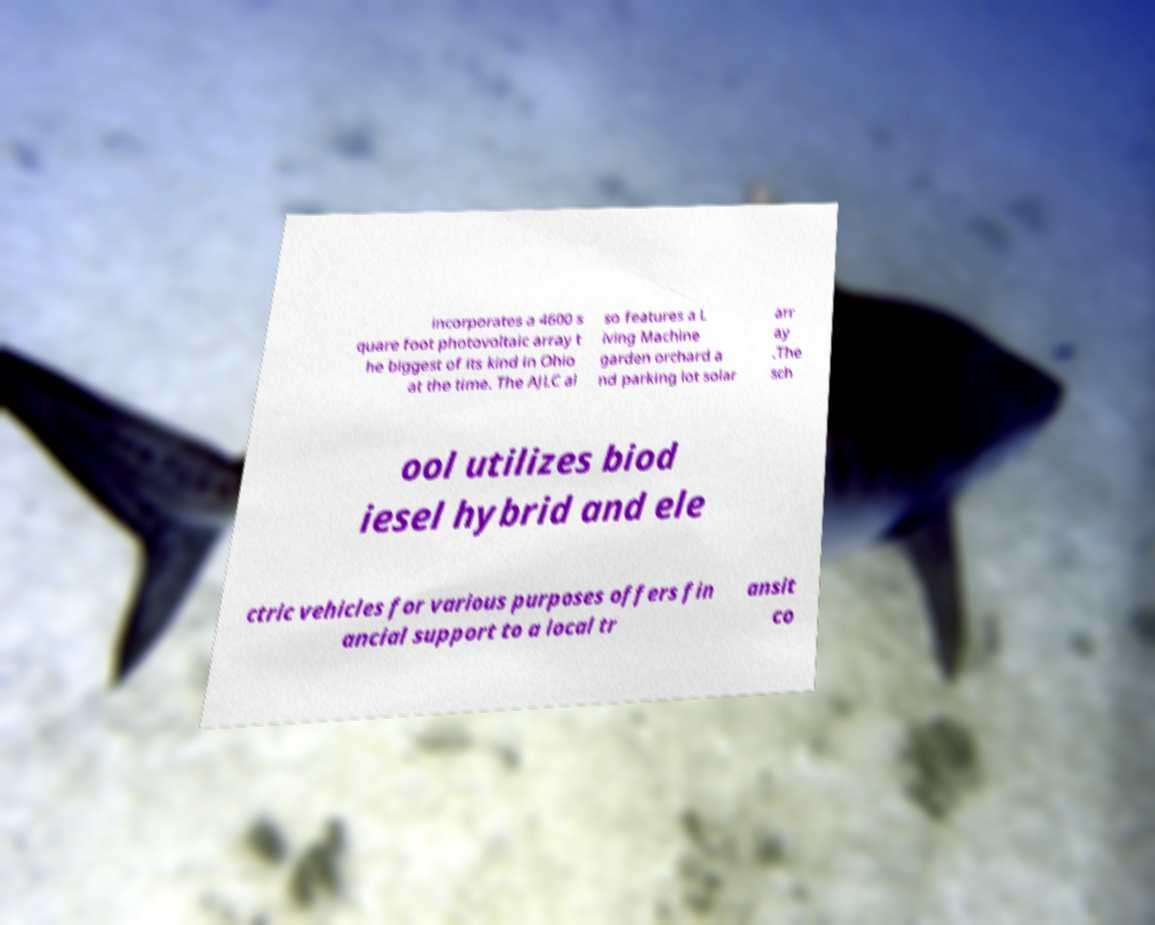I need the written content from this picture converted into text. Can you do that? incorporates a 4600 s quare foot photovoltaic array t he biggest of its kind in Ohio at the time. The AJLC al so features a L iving Machine garden orchard a nd parking lot solar arr ay .The sch ool utilizes biod iesel hybrid and ele ctric vehicles for various purposes offers fin ancial support to a local tr ansit co 